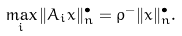<formula> <loc_0><loc_0><loc_500><loc_500>\max _ { i } \| A _ { i } x \| ^ { \bullet } _ { n } = \rho ^ { - } \| x \| ^ { \bullet } _ { n } .</formula> 